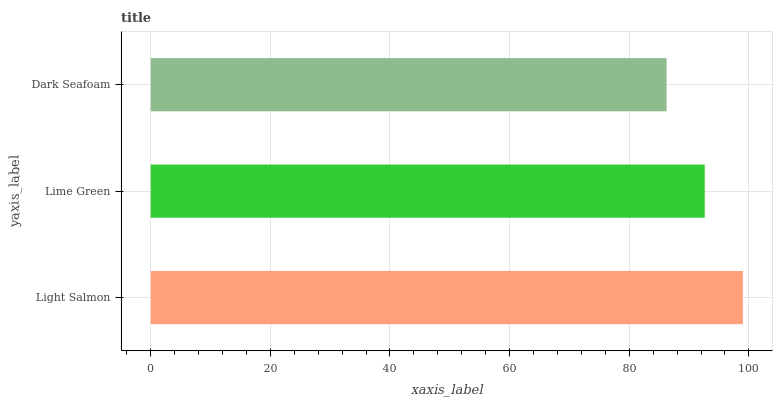Is Dark Seafoam the minimum?
Answer yes or no. Yes. Is Light Salmon the maximum?
Answer yes or no. Yes. Is Lime Green the minimum?
Answer yes or no. No. Is Lime Green the maximum?
Answer yes or no. No. Is Light Salmon greater than Lime Green?
Answer yes or no. Yes. Is Lime Green less than Light Salmon?
Answer yes or no. Yes. Is Lime Green greater than Light Salmon?
Answer yes or no. No. Is Light Salmon less than Lime Green?
Answer yes or no. No. Is Lime Green the high median?
Answer yes or no. Yes. Is Lime Green the low median?
Answer yes or no. Yes. Is Light Salmon the high median?
Answer yes or no. No. Is Dark Seafoam the low median?
Answer yes or no. No. 